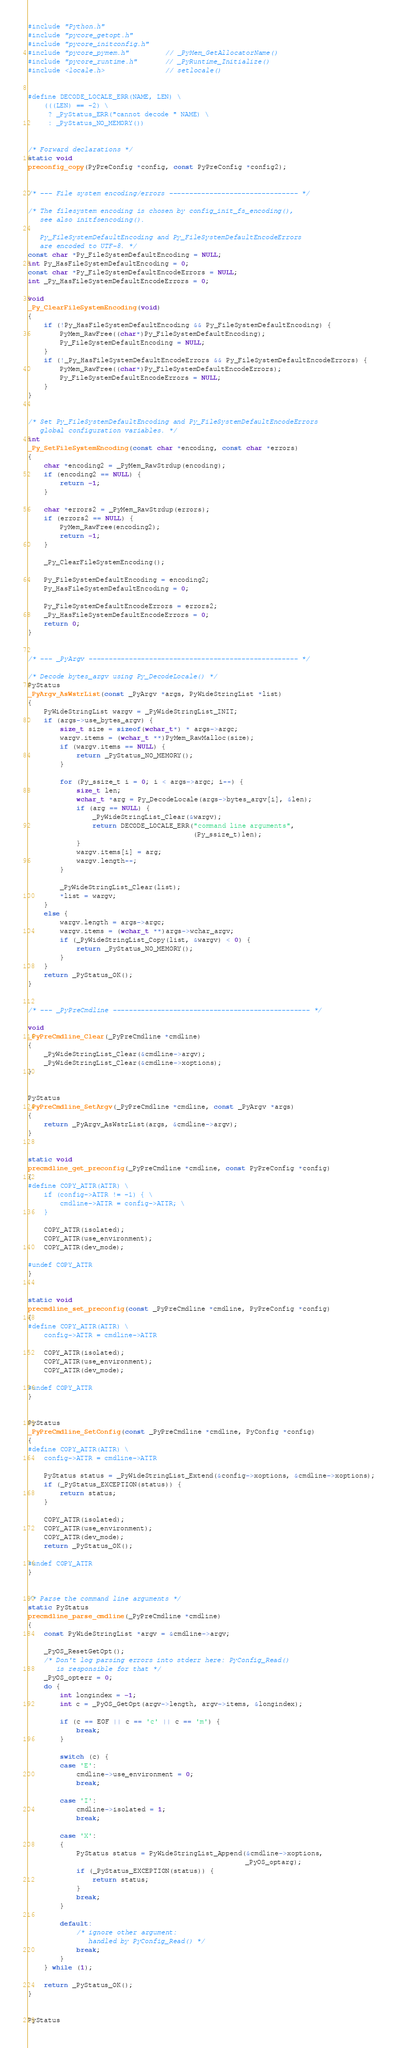Convert code to text. <code><loc_0><loc_0><loc_500><loc_500><_C_>#include "Python.h"
#include "pycore_getopt.h"
#include "pycore_initconfig.h"
#include "pycore_pymem.h"         // _PyMem_GetAllocatorName()
#include "pycore_runtime.h"       // _PyRuntime_Initialize()
#include <locale.h>               // setlocale()


#define DECODE_LOCALE_ERR(NAME, LEN) \
    (((LEN) == -2) \
     ? _PyStatus_ERR("cannot decode " NAME) \
     : _PyStatus_NO_MEMORY())


/* Forward declarations */
static void
preconfig_copy(PyPreConfig *config, const PyPreConfig *config2);


/* --- File system encoding/errors -------------------------------- */

/* The filesystem encoding is chosen by config_init_fs_encoding(),
   see also initfsencoding().

   Py_FileSystemDefaultEncoding and Py_FileSystemDefaultEncodeErrors
   are encoded to UTF-8. */
const char *Py_FileSystemDefaultEncoding = NULL;
int Py_HasFileSystemDefaultEncoding = 0;
const char *Py_FileSystemDefaultEncodeErrors = NULL;
int _Py_HasFileSystemDefaultEncodeErrors = 0;

void
_Py_ClearFileSystemEncoding(void)
{
    if (!Py_HasFileSystemDefaultEncoding && Py_FileSystemDefaultEncoding) {
        PyMem_RawFree((char*)Py_FileSystemDefaultEncoding);
        Py_FileSystemDefaultEncoding = NULL;
    }
    if (!_Py_HasFileSystemDefaultEncodeErrors && Py_FileSystemDefaultEncodeErrors) {
        PyMem_RawFree((char*)Py_FileSystemDefaultEncodeErrors);
        Py_FileSystemDefaultEncodeErrors = NULL;
    }
}


/* Set Py_FileSystemDefaultEncoding and Py_FileSystemDefaultEncodeErrors
   global configuration variables. */
int
_Py_SetFileSystemEncoding(const char *encoding, const char *errors)
{
    char *encoding2 = _PyMem_RawStrdup(encoding);
    if (encoding2 == NULL) {
        return -1;
    }

    char *errors2 = _PyMem_RawStrdup(errors);
    if (errors2 == NULL) {
        PyMem_RawFree(encoding2);
        return -1;
    }

    _Py_ClearFileSystemEncoding();

    Py_FileSystemDefaultEncoding = encoding2;
    Py_HasFileSystemDefaultEncoding = 0;

    Py_FileSystemDefaultEncodeErrors = errors2;
    _Py_HasFileSystemDefaultEncodeErrors = 0;
    return 0;
}


/* --- _PyArgv ---------------------------------------------------- */

/* Decode bytes_argv using Py_DecodeLocale() */
PyStatus
_PyArgv_AsWstrList(const _PyArgv *args, PyWideStringList *list)
{
    PyWideStringList wargv = _PyWideStringList_INIT;
    if (args->use_bytes_argv) {
        size_t size = sizeof(wchar_t*) * args->argc;
        wargv.items = (wchar_t **)PyMem_RawMalloc(size);
        if (wargv.items == NULL) {
            return _PyStatus_NO_MEMORY();
        }

        for (Py_ssize_t i = 0; i < args->argc; i++) {
            size_t len;
            wchar_t *arg = Py_DecodeLocale(args->bytes_argv[i], &len);
            if (arg == NULL) {
                _PyWideStringList_Clear(&wargv);
                return DECODE_LOCALE_ERR("command line arguments",
                                         (Py_ssize_t)len);
            }
            wargv.items[i] = arg;
            wargv.length++;
        }

        _PyWideStringList_Clear(list);
        *list = wargv;
    }
    else {
        wargv.length = args->argc;
        wargv.items = (wchar_t **)args->wchar_argv;
        if (_PyWideStringList_Copy(list, &wargv) < 0) {
            return _PyStatus_NO_MEMORY();
        }
    }
    return _PyStatus_OK();
}


/* --- _PyPreCmdline ------------------------------------------------- */

void
_PyPreCmdline_Clear(_PyPreCmdline *cmdline)
{
    _PyWideStringList_Clear(&cmdline->argv);
    _PyWideStringList_Clear(&cmdline->xoptions);
}


PyStatus
_PyPreCmdline_SetArgv(_PyPreCmdline *cmdline, const _PyArgv *args)
{
    return _PyArgv_AsWstrList(args, &cmdline->argv);
}


static void
precmdline_get_preconfig(_PyPreCmdline *cmdline, const PyPreConfig *config)
{
#define COPY_ATTR(ATTR) \
    if (config->ATTR != -1) { \
        cmdline->ATTR = config->ATTR; \
    }

    COPY_ATTR(isolated);
    COPY_ATTR(use_environment);
    COPY_ATTR(dev_mode);

#undef COPY_ATTR
}


static void
precmdline_set_preconfig(const _PyPreCmdline *cmdline, PyPreConfig *config)
{
#define COPY_ATTR(ATTR) \
    config->ATTR = cmdline->ATTR

    COPY_ATTR(isolated);
    COPY_ATTR(use_environment);
    COPY_ATTR(dev_mode);

#undef COPY_ATTR
}


PyStatus
_PyPreCmdline_SetConfig(const _PyPreCmdline *cmdline, PyConfig *config)
{
#define COPY_ATTR(ATTR) \
    config->ATTR = cmdline->ATTR

    PyStatus status = _PyWideStringList_Extend(&config->xoptions, &cmdline->xoptions);
    if (_PyStatus_EXCEPTION(status)) {
        return status;
    }

    COPY_ATTR(isolated);
    COPY_ATTR(use_environment);
    COPY_ATTR(dev_mode);
    return _PyStatus_OK();

#undef COPY_ATTR
}


/* Parse the command line arguments */
static PyStatus
precmdline_parse_cmdline(_PyPreCmdline *cmdline)
{
    const PyWideStringList *argv = &cmdline->argv;

    _PyOS_ResetGetOpt();
    /* Don't log parsing errors into stderr here: PyConfig_Read()
       is responsible for that */
    _PyOS_opterr = 0;
    do {
        int longindex = -1;
        int c = _PyOS_GetOpt(argv->length, argv->items, &longindex);

        if (c == EOF || c == 'c' || c == 'm') {
            break;
        }

        switch (c) {
        case 'E':
            cmdline->use_environment = 0;
            break;

        case 'I':
            cmdline->isolated = 1;
            break;

        case 'X':
        {
            PyStatus status = PyWideStringList_Append(&cmdline->xoptions,
                                                      _PyOS_optarg);
            if (_PyStatus_EXCEPTION(status)) {
                return status;
            }
            break;
        }

        default:
            /* ignore other argument:
               handled by PyConfig_Read() */
            break;
        }
    } while (1);

    return _PyStatus_OK();
}


PyStatus</code> 